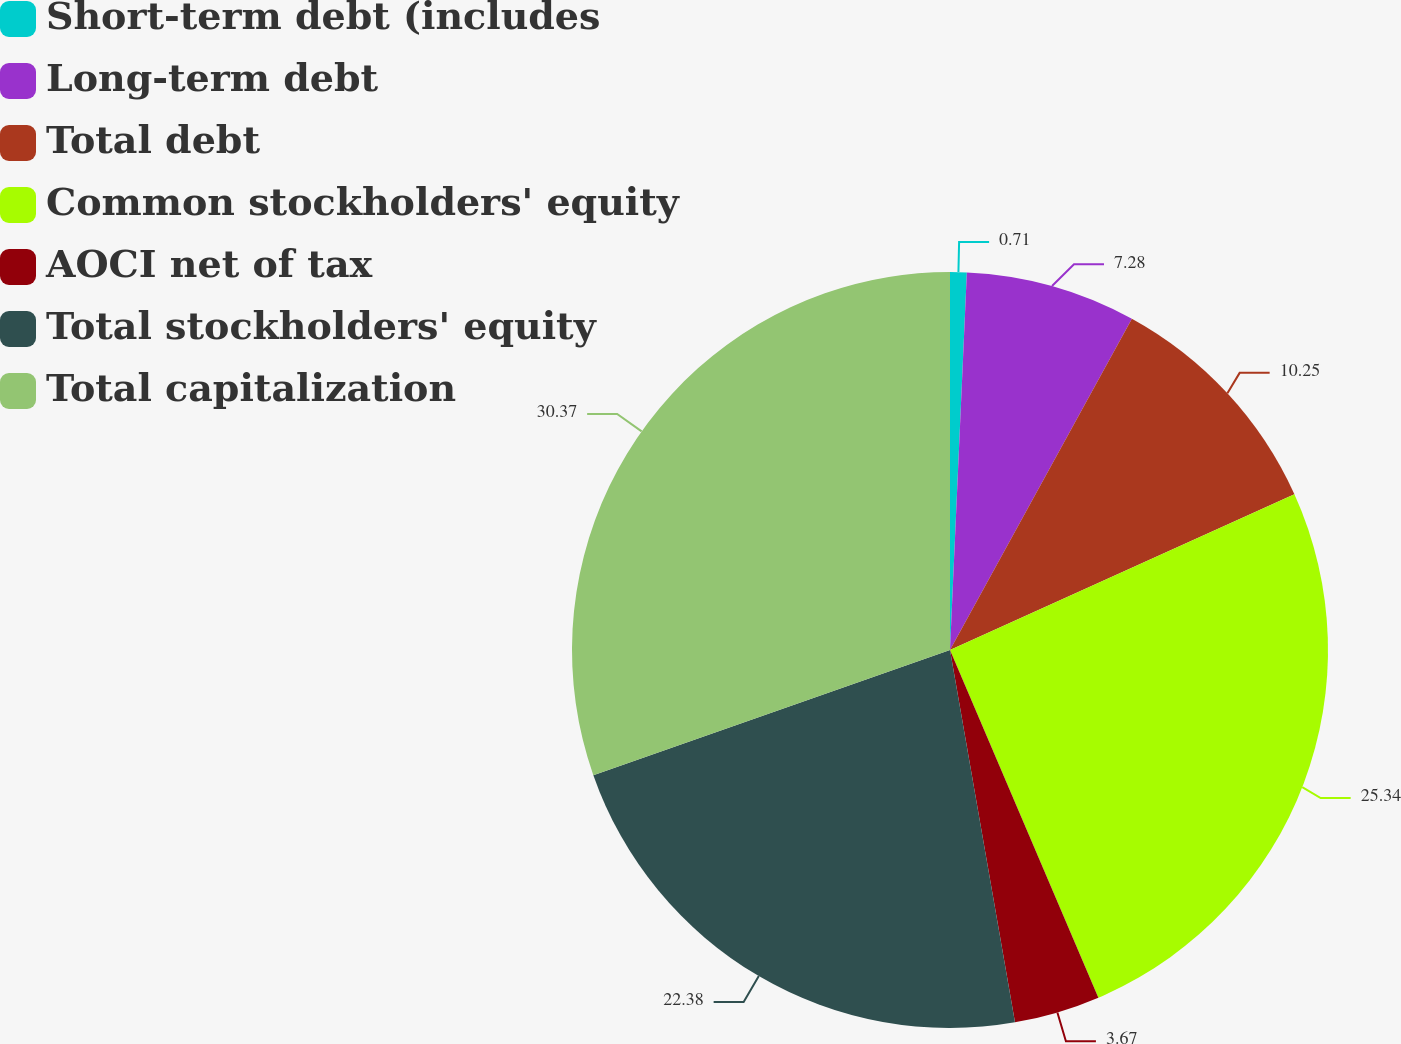Convert chart. <chart><loc_0><loc_0><loc_500><loc_500><pie_chart><fcel>Short-term debt (includes<fcel>Long-term debt<fcel>Total debt<fcel>Common stockholders' equity<fcel>AOCI net of tax<fcel>Total stockholders' equity<fcel>Total capitalization<nl><fcel>0.71%<fcel>7.28%<fcel>10.25%<fcel>25.34%<fcel>3.67%<fcel>22.38%<fcel>30.37%<nl></chart> 